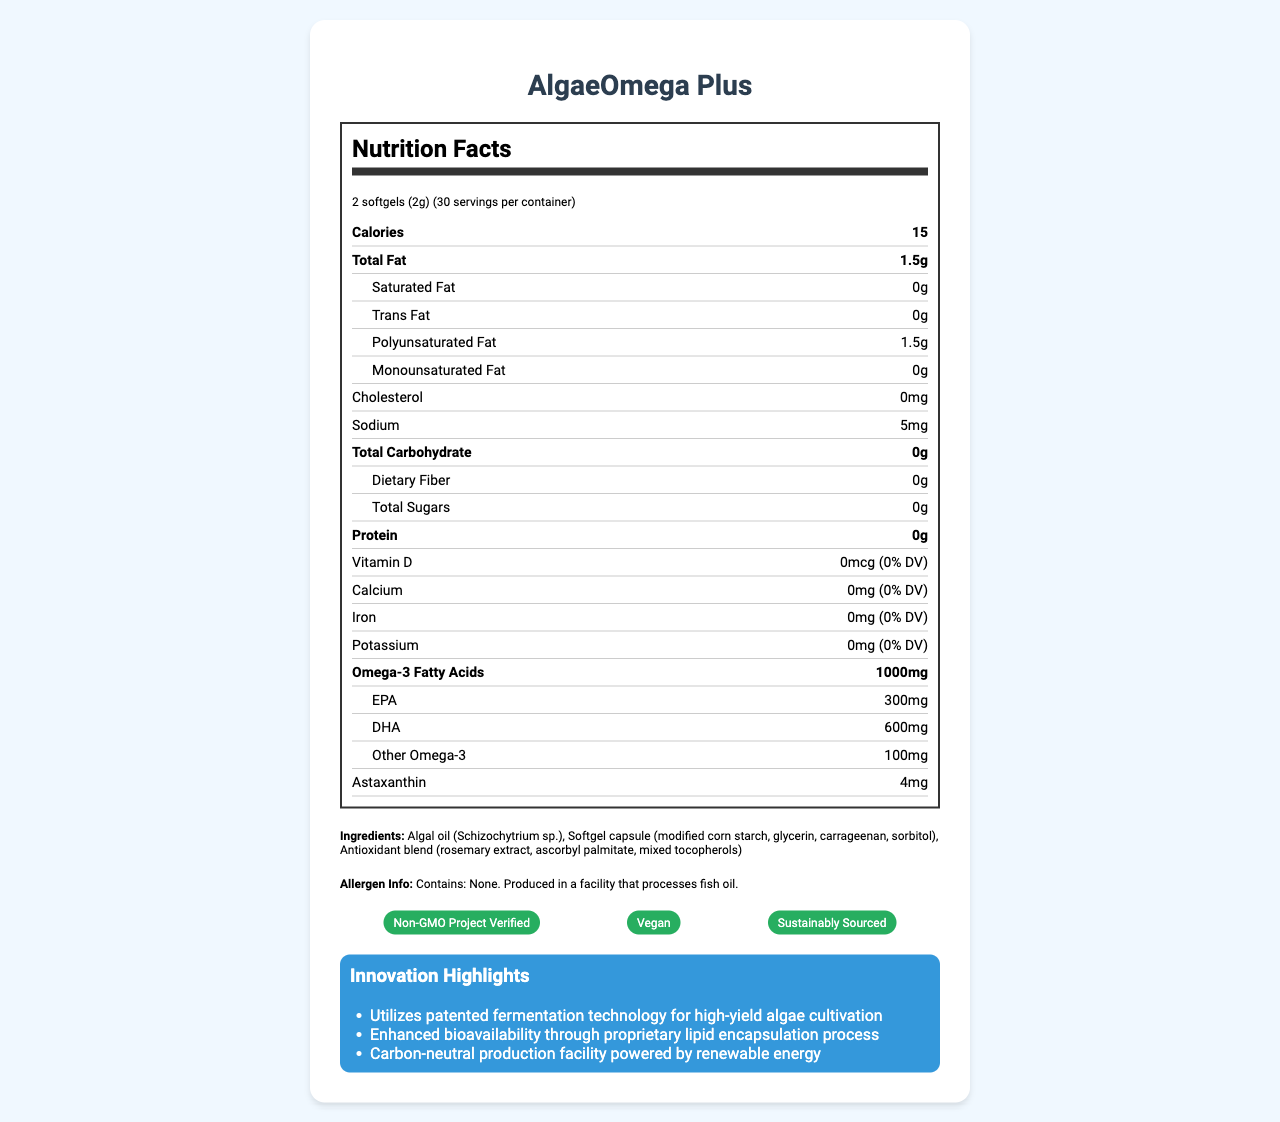what is the serving size for AlgaeOmega Plus? The document specifically notes that the serving size for AlgaeOmega Plus is 2 softgels, weighing a total of 2 grams.
Answer: 2 softgels (2g) how many calories are in one serving? The document indicates that there are 15 calories per serving.
Answer: 15 what types of fat are included in the supplement, and in what amounts? The nutrition label details the amounts for total fat and breaks it down into saturated, trans, polyunsaturated, and monounsaturated fats.
Answer: Total Fat: 1.5g, Saturated Fat: 0g, Trans Fat: 0g, Polyunsaturated Fat: 1.5g, Monounsaturated Fat: 0g what is the source of the omega-3 fatty acids in the supplement? The ingredients list shows that algal oil (Schizochytrium sp.) is the source of the omega-3 fatty acids.
Answer: Algal oil (Schizochytrium sp.) how much sodium is present in each serving? The nutrition label lists sodium content as 5mg per serving.
Answer: 5mg Which certification does the product NOT have? A. Non-GMO Project Verified B. Organic C. Vegan D. Sustainably Sourced The certifications listed are Non-GMO Project Verified, Vegan, and Sustainably Sourced, but Organic certification is not mentioned.
Answer: B. Organic What is the primary innovation method used for high-yield algae cultivation? I. Genetic modification II. Chemical synthesis III. Patented fermentation technology IV. Marine harvesting The document describes that the product uses patented fermentation technology for high-yield algae cultivation.
Answer: III. Patented fermentation technology Is the supplement produced in a facility that processes fish oil? The allergen information states that while the product contains no allergens, it is produced in a facility that processes fish oil.
Answer: Yes Summarize the main innovations and sustainability features of AlgaeOmega Plus. The summary captures the key points: innovative methods for production and bioavailability, and the comprehensive sustainability features from production to packaging.
Answer: AlgaeOmega Plus utilizes innovative methods such as patented fermentation technology and proprietary lipid encapsulation to enhance bioavailability, and operates in a carbon-neutral facility. Its sustainability features include reducing pressure on marine ecosystems, water-efficient production, and biodegradable packaging. How much DHA is present in a serving? The nutrition label specifies that each serving contains 600mg of DHA.
Answer: 600mg Can you determine the price of AlgaeOmega Plus from the document? The document does not provide any details regarding the price of AlgaeOmega Plus.
Answer: Not enough information 